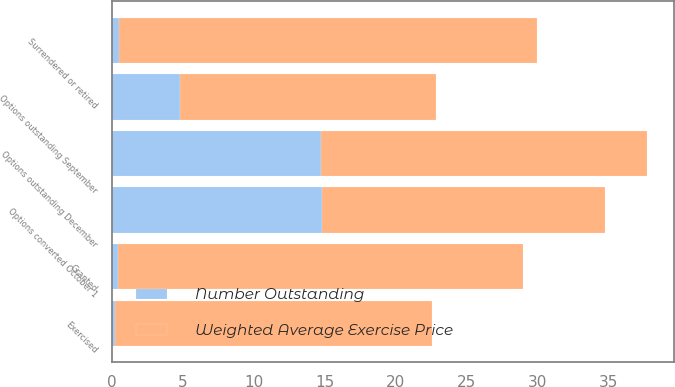<chart> <loc_0><loc_0><loc_500><loc_500><stacked_bar_chart><ecel><fcel>Options outstanding December<fcel>Granted<fcel>Exercised<fcel>Surrendered or retired<fcel>Options outstanding September<fcel>Options converted October 1<nl><fcel>Number Outstanding<fcel>14.7<fcel>0.4<fcel>0.2<fcel>0.5<fcel>4.8<fcel>14.8<nl><fcel>Weighted Average Exercise Price<fcel>23<fcel>28.53<fcel>22.37<fcel>29.4<fcel>17.99<fcel>19.94<nl></chart> 